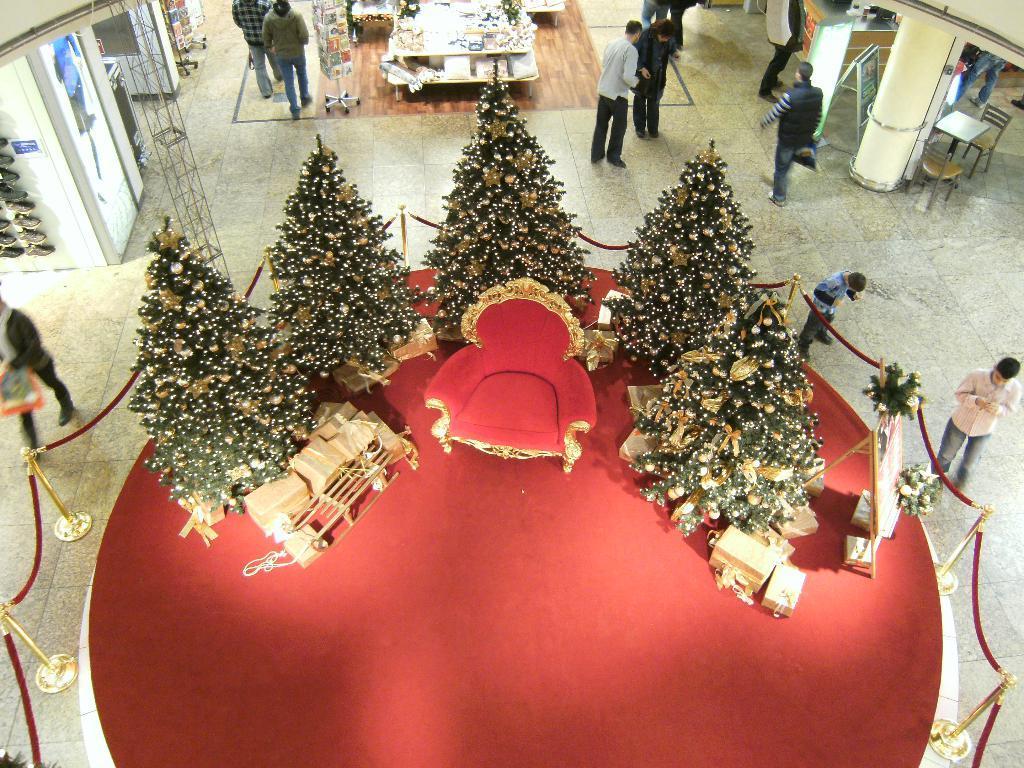In one or two sentences, can you explain what this image depicts? These are the christmas trees, which are decorated. I can see a chair. I think these are the gift boxes. This looks like a board, which is decorated with the flower bouquets. I can see few people standing and few people walking. I think this picture was taken inside the building. I can see a table with few objects on it. I think these are the shops. This looks like a red carpet, which is on the floor. 